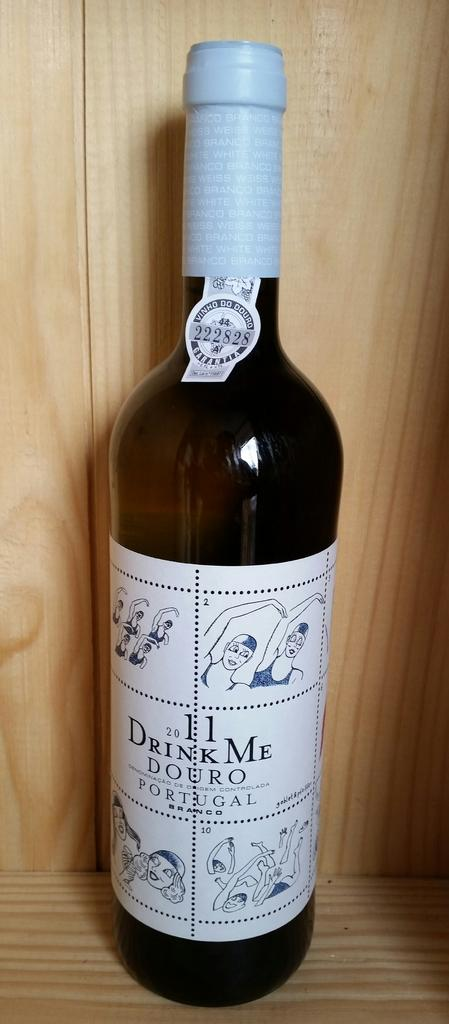<image>
Relay a brief, clear account of the picture shown. 2011 Drink Me Douro cost $119.97 a bottle. 